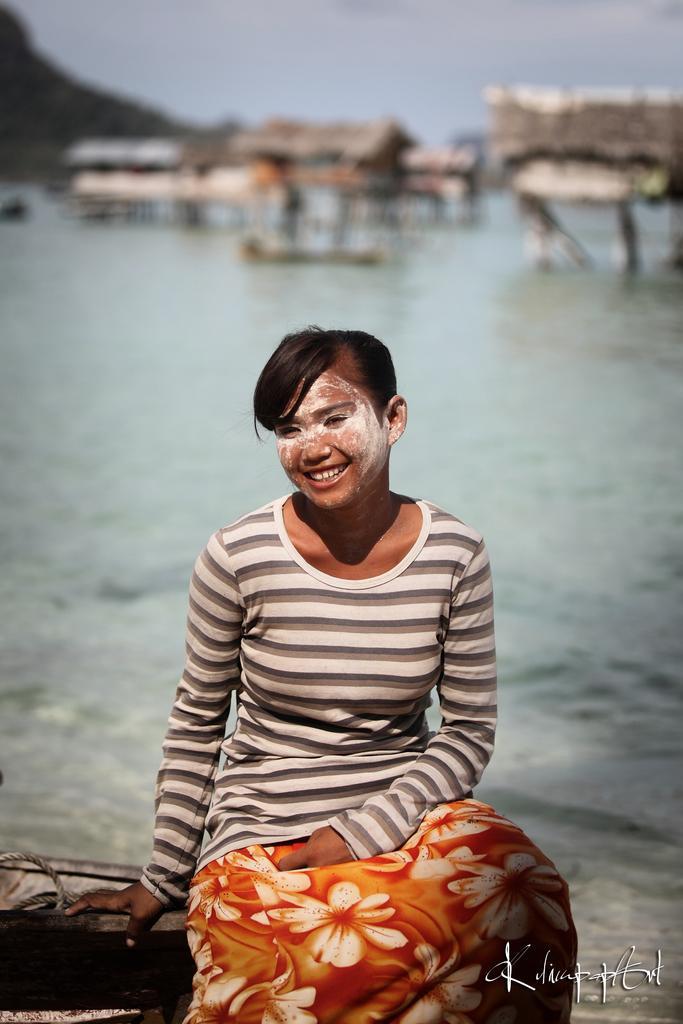Describe this image in one or two sentences. In this image I can see a girl is sitting and smiling, she wore white and other colors t-shirt. Behind her there is the water, at the top it is the sky. 